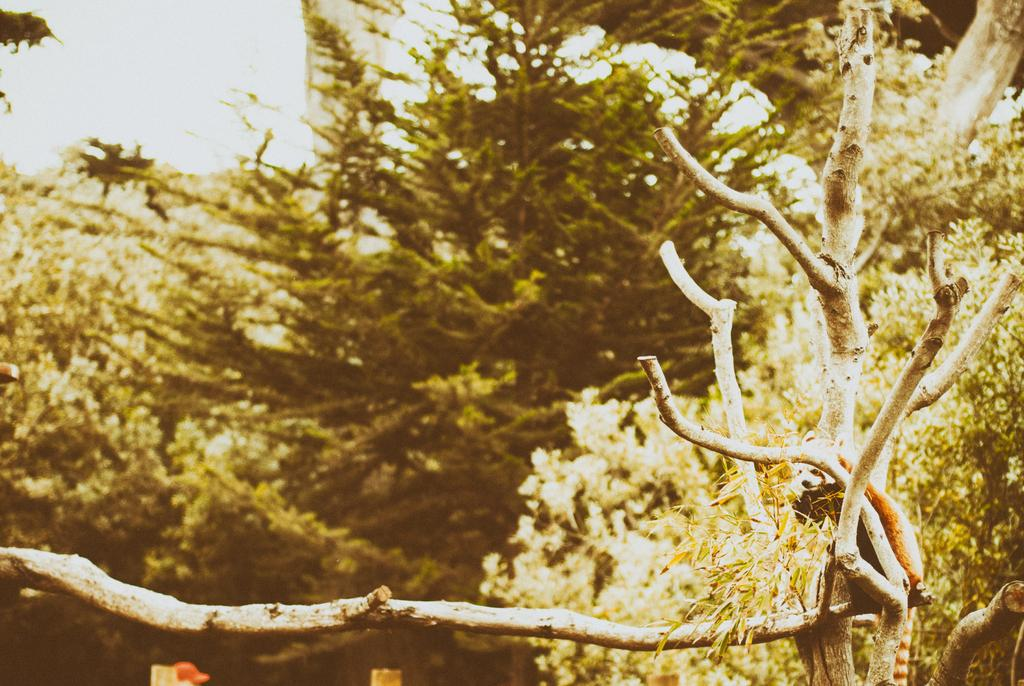What is on the branch in the image? There is an animal on a branch in the image. What type of vegetation can be seen in the image? There are trees in the image. What can be seen in the background of the image? The sky is visible in the background of the image. What type of brass instrument is the animal playing in the image? There is no brass instrument present in the image; it features an animal on a branch and trees in the background. 